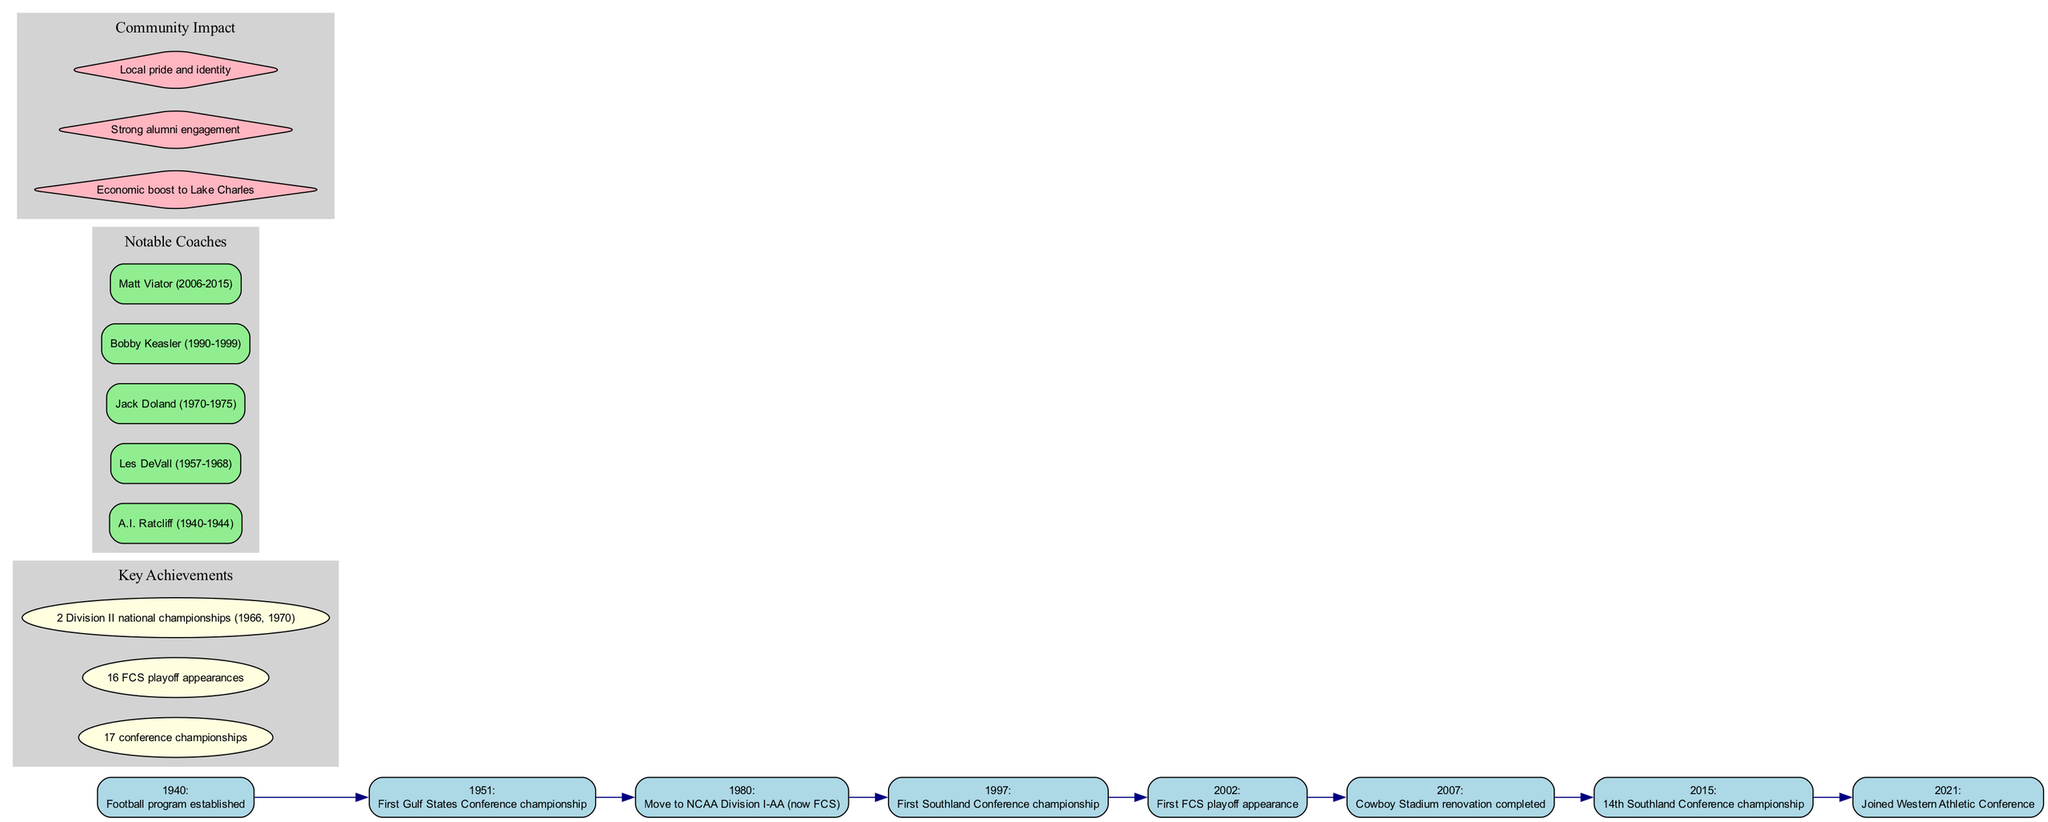What year was the football program established? The diagram indicates that the football program at McNeese State University was established in 1940. This information is found in the timeline at the start.
Answer: 1940 How many Southland Conference championships has the program won? The key achievements section of the diagram lists that McNeese State's football program has won 17 conference championships. This figure can be directly found among the listed achievements.
Answer: 17 Who was the coach from 2006 to 2015? By looking at the notable coaches section, we find that Matt Viator served as a coach during the year range from 2006 to 2015. This specific timeframe matches one of the entries in the coach list.
Answer: Matt Viator What significant event happened in 2002? Referring to the timeline, the year 2002 marks the first FCS playoff appearance for the football program. This is clearly stated next to the respective year node.
Answer: First FCS playoff appearance Which milestone signifies the program's move to NCAA Division I-AA? The diagram shows the milestone for moving to NCAA Division I-AA (now FCS) happened in 1980. This milestone is included chronologically in the timeline.
Answer: 1980 What is one aspect of the community impact noted in the diagram? The community impact section lists several points, one being "Local pride and identity." This can be directly cited from the impacts section of the diagram.
Answer: Local pride and identity How many FCS playoff appearances has McNeese State made? According to the key achievements area, McNeese State University has made 16 FCS playoff appearances. This information is summarized in the achievements section.
Answer: 16 What year did McNeese join the Western Athletic Conference? In the timeline, the year 2021 is highlighted as the year McNeese State University joined the Western Athletic Conference. This node in the timeline provides this specific detail.
Answer: 2021 Which coach's tenure included winning the Division II national championships? By examining the notable coaches' section, we find that none of them is specifically noted for winning Division II national championships as a coach; however, this achievement is a general part of the history mentioned. Thus, there isn't a direct match from the coach list.
Answer: N/A 